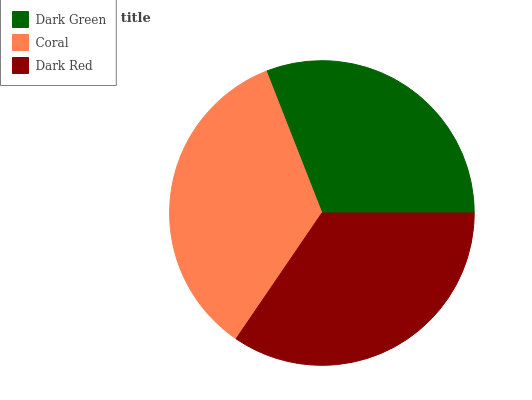Is Dark Green the minimum?
Answer yes or no. Yes. Is Coral the maximum?
Answer yes or no. Yes. Is Dark Red the minimum?
Answer yes or no. No. Is Dark Red the maximum?
Answer yes or no. No. Is Coral greater than Dark Red?
Answer yes or no. Yes. Is Dark Red less than Coral?
Answer yes or no. Yes. Is Dark Red greater than Coral?
Answer yes or no. No. Is Coral less than Dark Red?
Answer yes or no. No. Is Dark Red the high median?
Answer yes or no. Yes. Is Dark Red the low median?
Answer yes or no. Yes. Is Dark Green the high median?
Answer yes or no. No. Is Dark Green the low median?
Answer yes or no. No. 